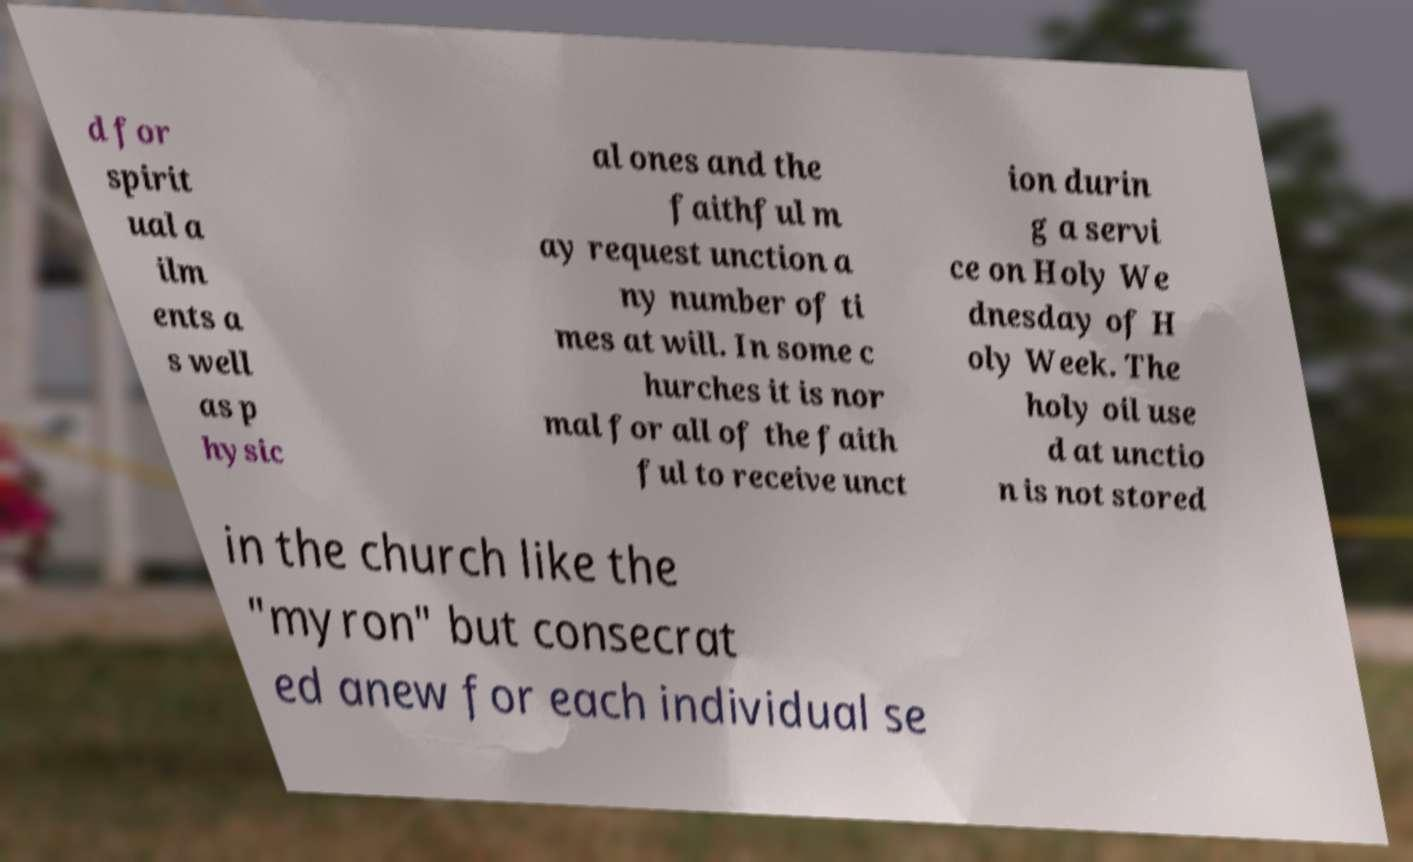Can you accurately transcribe the text from the provided image for me? d for spirit ual a ilm ents a s well as p hysic al ones and the faithful m ay request unction a ny number of ti mes at will. In some c hurches it is nor mal for all of the faith ful to receive unct ion durin g a servi ce on Holy We dnesday of H oly Week. The holy oil use d at unctio n is not stored in the church like the "myron" but consecrat ed anew for each individual se 